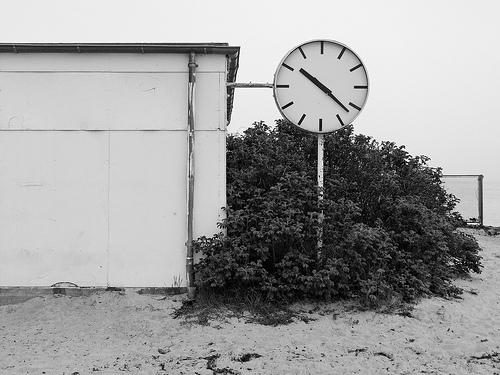State the main color theme in the image. The image is mainly composed of white, black, and green colors. Describe the position of the clock with respect to the bush in the image. The clock is mounted on a pole that is in between the bush and the white building. Provide a brief overview of the main features in the image. A white clock on a pole, a bush next to a building, sandy ground, and a cloudy sky are the main elements in this image. Describe what is happening with the bush in the image. A large green bush, overgrown with shrubbery, is situated next to a white building and a sandy ground. Mention the main objects in the image along with their colors. There's a white clock mounted on a pole, a large green bush, white sandy ground, and a gray fence. State the type of ground in the image and the color of the sky. The ground is sandy, while the sky is white in the image. Write a sentence about the clock in the image, including its color and position. A white and black clock is standing on a pole, displaying a time of 4:23. Mention the type of setting for the image and the time of day depicted. The image portrays an outdoor scene taken during daytime with clear skies. Write a sentence about the fence in the image. There is a gray fence found behind the large bush in the scene. Describe the appearance of the pole in the image. The thin, rusty pole has paint peeling off and is attached to a large clock. 